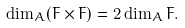<formula> <loc_0><loc_0><loc_500><loc_500>\dim _ { A } ( F \times F ) = 2 \dim _ { A } F .</formula> 